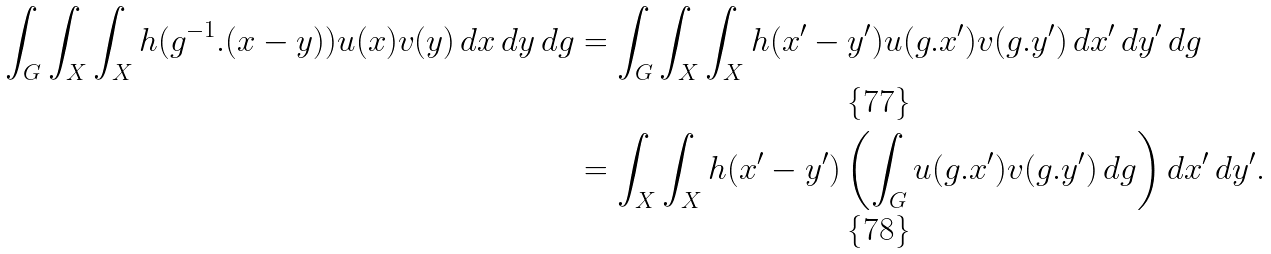<formula> <loc_0><loc_0><loc_500><loc_500>\int _ { G } \int _ { X } \int _ { X } h ( g ^ { - 1 } . ( x - y ) ) u ( x ) v ( y ) \, d x \, d y \, d g & = \int _ { G } \int _ { X } \int _ { X } h ( x ^ { \prime } - y ^ { \prime } ) u ( g . x ^ { \prime } ) v ( g . y ^ { \prime } ) \, d x ^ { \prime } \, d y ^ { \prime } \, d g \\ & = \int _ { X } \int _ { X } h ( x ^ { \prime } - y ^ { \prime } ) \left ( \int _ { G } u ( g . x ^ { \prime } ) v ( g . y ^ { \prime } ) \, d g \right ) d x ^ { \prime } \, d y ^ { \prime } .</formula> 